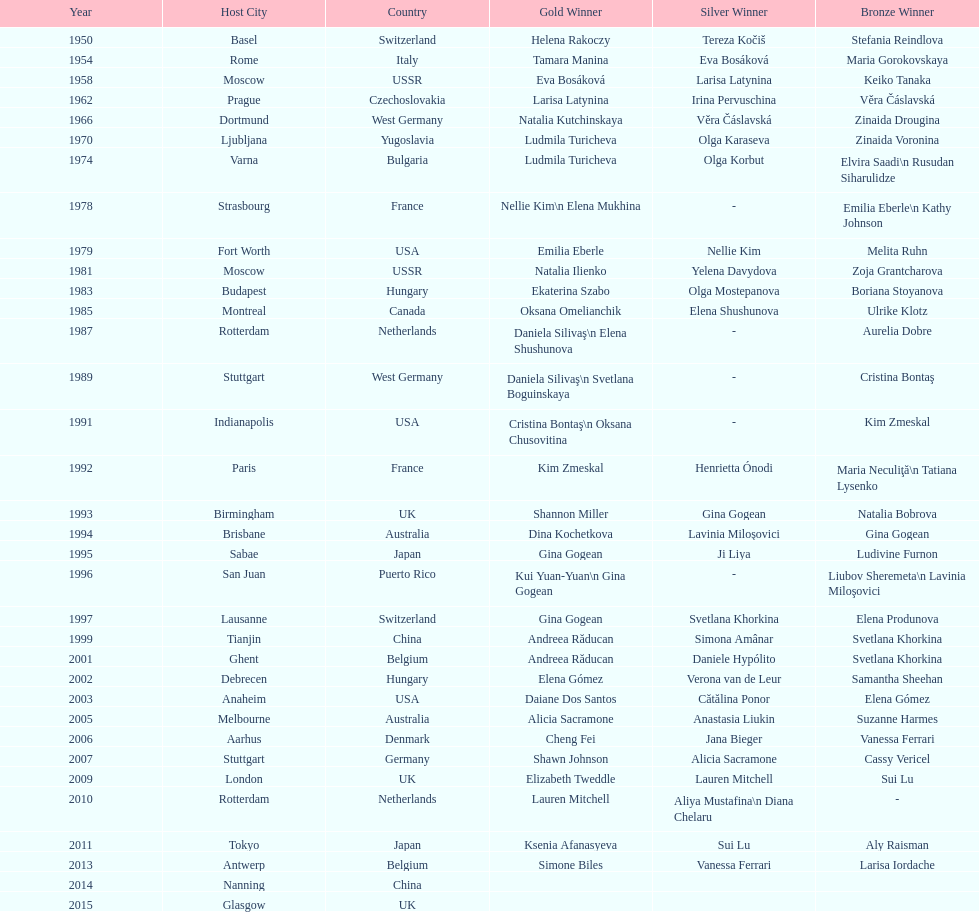What is the number of times a brazilian has won a medal? 2. 